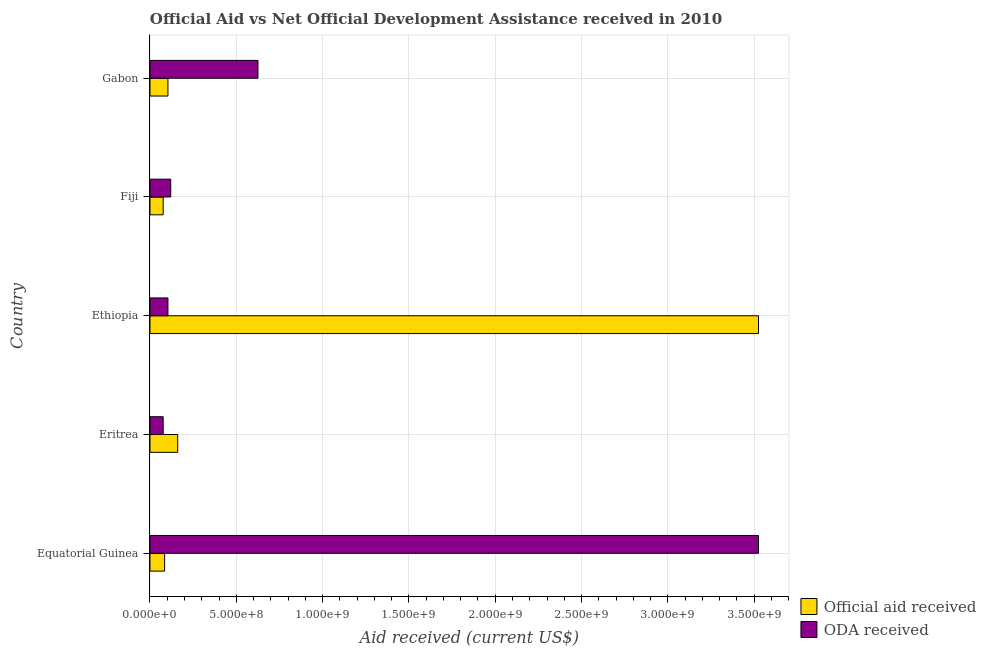How many different coloured bars are there?
Make the answer very short. 2. How many groups of bars are there?
Offer a terse response. 5. Are the number of bars per tick equal to the number of legend labels?
Give a very brief answer. Yes. How many bars are there on the 4th tick from the top?
Your response must be concise. 2. What is the label of the 2nd group of bars from the top?
Provide a short and direct response. Fiji. In how many cases, is the number of bars for a given country not equal to the number of legend labels?
Provide a short and direct response. 0. What is the official aid received in Ethiopia?
Keep it short and to the point. 3.53e+09. Across all countries, what is the maximum official aid received?
Provide a succinct answer. 3.53e+09. Across all countries, what is the minimum oda received?
Your answer should be compact. 7.64e+07. In which country was the oda received maximum?
Offer a terse response. Equatorial Guinea. In which country was the oda received minimum?
Provide a short and direct response. Eritrea. What is the total official aid received in the graph?
Provide a short and direct response. 3.95e+09. What is the difference between the oda received in Equatorial Guinea and that in Gabon?
Keep it short and to the point. 2.90e+09. What is the difference between the oda received in Equatorial Guinea and the official aid received in Gabon?
Offer a very short reply. 3.42e+09. What is the average oda received per country?
Provide a short and direct response. 8.90e+08. What is the difference between the oda received and official aid received in Equatorial Guinea?
Ensure brevity in your answer.  3.44e+09. What is the ratio of the official aid received in Eritrea to that in Gabon?
Give a very brief answer. 1.54. Is the oda received in Ethiopia less than that in Gabon?
Keep it short and to the point. Yes. Is the difference between the oda received in Equatorial Guinea and Fiji greater than the difference between the official aid received in Equatorial Guinea and Fiji?
Keep it short and to the point. Yes. What is the difference between the highest and the second highest oda received?
Provide a succinct answer. 2.90e+09. What is the difference between the highest and the lowest official aid received?
Give a very brief answer. 3.45e+09. Is the sum of the oda received in Equatorial Guinea and Gabon greater than the maximum official aid received across all countries?
Keep it short and to the point. Yes. What does the 1st bar from the top in Gabon represents?
Provide a short and direct response. ODA received. What does the 2nd bar from the bottom in Equatorial Guinea represents?
Give a very brief answer. ODA received. Are all the bars in the graph horizontal?
Ensure brevity in your answer.  Yes. How many countries are there in the graph?
Offer a very short reply. 5. Does the graph contain grids?
Provide a short and direct response. Yes. Where does the legend appear in the graph?
Your answer should be compact. Bottom right. How many legend labels are there?
Provide a short and direct response. 2. What is the title of the graph?
Your answer should be very brief. Official Aid vs Net Official Development Assistance received in 2010 . What is the label or title of the X-axis?
Give a very brief answer. Aid received (current US$). What is the label or title of the Y-axis?
Provide a short and direct response. Country. What is the Aid received (current US$) in Official aid received in Equatorial Guinea?
Offer a very short reply. 8.47e+07. What is the Aid received (current US$) in ODA received in Equatorial Guinea?
Your answer should be compact. 3.53e+09. What is the Aid received (current US$) in Official aid received in Eritrea?
Your answer should be compact. 1.61e+08. What is the Aid received (current US$) in ODA received in Eritrea?
Your response must be concise. 7.64e+07. What is the Aid received (current US$) in Official aid received in Ethiopia?
Make the answer very short. 3.53e+09. What is the Aid received (current US$) in ODA received in Ethiopia?
Provide a succinct answer. 1.04e+08. What is the Aid received (current US$) of Official aid received in Fiji?
Your answer should be compact. 7.64e+07. What is the Aid received (current US$) in ODA received in Fiji?
Your response must be concise. 1.20e+08. What is the Aid received (current US$) of Official aid received in Gabon?
Ensure brevity in your answer.  1.04e+08. What is the Aid received (current US$) in ODA received in Gabon?
Provide a succinct answer. 6.26e+08. Across all countries, what is the maximum Aid received (current US$) in Official aid received?
Your response must be concise. 3.53e+09. Across all countries, what is the maximum Aid received (current US$) of ODA received?
Provide a short and direct response. 3.53e+09. Across all countries, what is the minimum Aid received (current US$) in Official aid received?
Ensure brevity in your answer.  7.64e+07. Across all countries, what is the minimum Aid received (current US$) in ODA received?
Your answer should be very brief. 7.64e+07. What is the total Aid received (current US$) in Official aid received in the graph?
Make the answer very short. 3.95e+09. What is the total Aid received (current US$) of ODA received in the graph?
Offer a very short reply. 4.45e+09. What is the difference between the Aid received (current US$) of Official aid received in Equatorial Guinea and that in Eritrea?
Provide a succinct answer. -7.58e+07. What is the difference between the Aid received (current US$) in ODA received in Equatorial Guinea and that in Eritrea?
Your answer should be compact. 3.45e+09. What is the difference between the Aid received (current US$) of Official aid received in Equatorial Guinea and that in Ethiopia?
Give a very brief answer. -3.44e+09. What is the difference between the Aid received (current US$) of ODA received in Equatorial Guinea and that in Ethiopia?
Provide a short and direct response. 3.42e+09. What is the difference between the Aid received (current US$) in Official aid received in Equatorial Guinea and that in Fiji?
Keep it short and to the point. 8.31e+06. What is the difference between the Aid received (current US$) in ODA received in Equatorial Guinea and that in Fiji?
Your response must be concise. 3.41e+09. What is the difference between the Aid received (current US$) in Official aid received in Equatorial Guinea and that in Gabon?
Ensure brevity in your answer.  -1.93e+07. What is the difference between the Aid received (current US$) of ODA received in Equatorial Guinea and that in Gabon?
Provide a succinct answer. 2.90e+09. What is the difference between the Aid received (current US$) of Official aid received in Eritrea and that in Ethiopia?
Provide a short and direct response. -3.36e+09. What is the difference between the Aid received (current US$) of ODA received in Eritrea and that in Ethiopia?
Your answer should be compact. -2.76e+07. What is the difference between the Aid received (current US$) in Official aid received in Eritrea and that in Fiji?
Offer a very short reply. 8.41e+07. What is the difference between the Aid received (current US$) of ODA received in Eritrea and that in Fiji?
Offer a terse response. -4.38e+07. What is the difference between the Aid received (current US$) of Official aid received in Eritrea and that in Gabon?
Offer a terse response. 5.65e+07. What is the difference between the Aid received (current US$) in ODA received in Eritrea and that in Gabon?
Make the answer very short. -5.49e+08. What is the difference between the Aid received (current US$) of Official aid received in Ethiopia and that in Fiji?
Give a very brief answer. 3.45e+09. What is the difference between the Aid received (current US$) of ODA received in Ethiopia and that in Fiji?
Give a very brief answer. -1.62e+07. What is the difference between the Aid received (current US$) of Official aid received in Ethiopia and that in Gabon?
Offer a terse response. 3.42e+09. What is the difference between the Aid received (current US$) of ODA received in Ethiopia and that in Gabon?
Make the answer very short. -5.22e+08. What is the difference between the Aid received (current US$) in Official aid received in Fiji and that in Gabon?
Provide a succinct answer. -2.76e+07. What is the difference between the Aid received (current US$) in ODA received in Fiji and that in Gabon?
Give a very brief answer. -5.05e+08. What is the difference between the Aid received (current US$) in Official aid received in Equatorial Guinea and the Aid received (current US$) in ODA received in Eritrea?
Keep it short and to the point. 8.31e+06. What is the difference between the Aid received (current US$) in Official aid received in Equatorial Guinea and the Aid received (current US$) in ODA received in Ethiopia?
Your answer should be very brief. -1.93e+07. What is the difference between the Aid received (current US$) of Official aid received in Equatorial Guinea and the Aid received (current US$) of ODA received in Fiji?
Offer a terse response. -3.55e+07. What is the difference between the Aid received (current US$) of Official aid received in Equatorial Guinea and the Aid received (current US$) of ODA received in Gabon?
Your answer should be very brief. -5.41e+08. What is the difference between the Aid received (current US$) of Official aid received in Eritrea and the Aid received (current US$) of ODA received in Ethiopia?
Ensure brevity in your answer.  5.65e+07. What is the difference between the Aid received (current US$) of Official aid received in Eritrea and the Aid received (current US$) of ODA received in Fiji?
Provide a short and direct response. 4.03e+07. What is the difference between the Aid received (current US$) in Official aid received in Eritrea and the Aid received (current US$) in ODA received in Gabon?
Your response must be concise. -4.65e+08. What is the difference between the Aid received (current US$) of Official aid received in Ethiopia and the Aid received (current US$) of ODA received in Fiji?
Your answer should be compact. 3.41e+09. What is the difference between the Aid received (current US$) in Official aid received in Ethiopia and the Aid received (current US$) in ODA received in Gabon?
Offer a terse response. 2.90e+09. What is the difference between the Aid received (current US$) of Official aid received in Fiji and the Aid received (current US$) of ODA received in Gabon?
Give a very brief answer. -5.49e+08. What is the average Aid received (current US$) of Official aid received per country?
Your answer should be compact. 7.90e+08. What is the average Aid received (current US$) of ODA received per country?
Give a very brief answer. 8.90e+08. What is the difference between the Aid received (current US$) of Official aid received and Aid received (current US$) of ODA received in Equatorial Guinea?
Provide a succinct answer. -3.44e+09. What is the difference between the Aid received (current US$) in Official aid received and Aid received (current US$) in ODA received in Eritrea?
Provide a succinct answer. 8.41e+07. What is the difference between the Aid received (current US$) in Official aid received and Aid received (current US$) in ODA received in Ethiopia?
Make the answer very short. 3.42e+09. What is the difference between the Aid received (current US$) of Official aid received and Aid received (current US$) of ODA received in Fiji?
Your answer should be compact. -4.38e+07. What is the difference between the Aid received (current US$) of Official aid received and Aid received (current US$) of ODA received in Gabon?
Make the answer very short. -5.22e+08. What is the ratio of the Aid received (current US$) in Official aid received in Equatorial Guinea to that in Eritrea?
Your answer should be very brief. 0.53. What is the ratio of the Aid received (current US$) of ODA received in Equatorial Guinea to that in Eritrea?
Offer a very short reply. 46.14. What is the ratio of the Aid received (current US$) of Official aid received in Equatorial Guinea to that in Ethiopia?
Offer a terse response. 0.02. What is the ratio of the Aid received (current US$) of ODA received in Equatorial Guinea to that in Ethiopia?
Provide a succinct answer. 33.9. What is the ratio of the Aid received (current US$) in Official aid received in Equatorial Guinea to that in Fiji?
Offer a terse response. 1.11. What is the ratio of the Aid received (current US$) in ODA received in Equatorial Guinea to that in Fiji?
Keep it short and to the point. 29.33. What is the ratio of the Aid received (current US$) in Official aid received in Equatorial Guinea to that in Gabon?
Offer a terse response. 0.81. What is the ratio of the Aid received (current US$) in ODA received in Equatorial Guinea to that in Gabon?
Ensure brevity in your answer.  5.64. What is the ratio of the Aid received (current US$) in Official aid received in Eritrea to that in Ethiopia?
Provide a succinct answer. 0.05. What is the ratio of the Aid received (current US$) of ODA received in Eritrea to that in Ethiopia?
Make the answer very short. 0.73. What is the ratio of the Aid received (current US$) in Official aid received in Eritrea to that in Fiji?
Ensure brevity in your answer.  2.1. What is the ratio of the Aid received (current US$) in ODA received in Eritrea to that in Fiji?
Provide a short and direct response. 0.64. What is the ratio of the Aid received (current US$) in Official aid received in Eritrea to that in Gabon?
Offer a very short reply. 1.54. What is the ratio of the Aid received (current US$) of ODA received in Eritrea to that in Gabon?
Make the answer very short. 0.12. What is the ratio of the Aid received (current US$) in Official aid received in Ethiopia to that in Fiji?
Make the answer very short. 46.14. What is the ratio of the Aid received (current US$) of ODA received in Ethiopia to that in Fiji?
Your answer should be very brief. 0.87. What is the ratio of the Aid received (current US$) in Official aid received in Ethiopia to that in Gabon?
Offer a terse response. 33.9. What is the ratio of the Aid received (current US$) of ODA received in Ethiopia to that in Gabon?
Give a very brief answer. 0.17. What is the ratio of the Aid received (current US$) of Official aid received in Fiji to that in Gabon?
Provide a succinct answer. 0.73. What is the ratio of the Aid received (current US$) of ODA received in Fiji to that in Gabon?
Give a very brief answer. 0.19. What is the difference between the highest and the second highest Aid received (current US$) of Official aid received?
Your response must be concise. 3.36e+09. What is the difference between the highest and the second highest Aid received (current US$) of ODA received?
Ensure brevity in your answer.  2.90e+09. What is the difference between the highest and the lowest Aid received (current US$) in Official aid received?
Make the answer very short. 3.45e+09. What is the difference between the highest and the lowest Aid received (current US$) in ODA received?
Ensure brevity in your answer.  3.45e+09. 